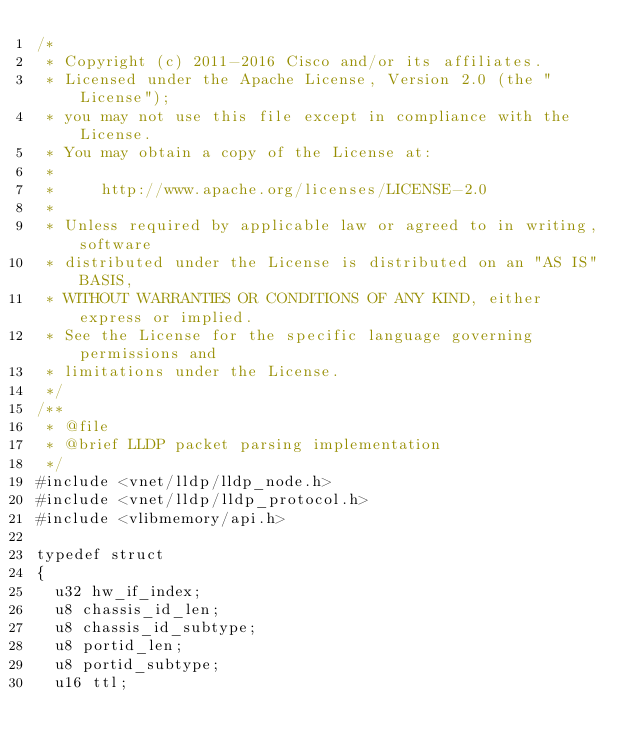<code> <loc_0><loc_0><loc_500><loc_500><_C_>/*
 * Copyright (c) 2011-2016 Cisco and/or its affiliates.
 * Licensed under the Apache License, Version 2.0 (the "License");
 * you may not use this file except in compliance with the License.
 * You may obtain a copy of the License at:
 *
 *     http://www.apache.org/licenses/LICENSE-2.0
 *
 * Unless required by applicable law or agreed to in writing, software
 * distributed under the License is distributed on an "AS IS" BASIS,
 * WITHOUT WARRANTIES OR CONDITIONS OF ANY KIND, either express or implied.
 * See the License for the specific language governing permissions and
 * limitations under the License.
 */
/**
 * @file
 * @brief LLDP packet parsing implementation
 */
#include <vnet/lldp/lldp_node.h>
#include <vnet/lldp/lldp_protocol.h>
#include <vlibmemory/api.h>

typedef struct
{
  u32 hw_if_index;
  u8 chassis_id_len;
  u8 chassis_id_subtype;
  u8 portid_len;
  u8 portid_subtype;
  u16 ttl;</code> 